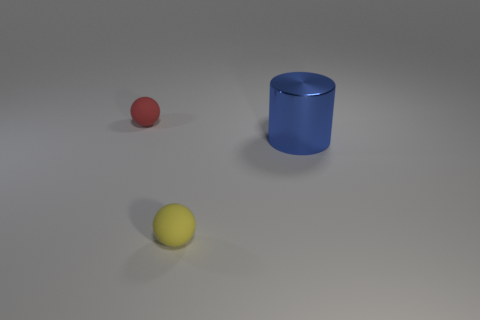Add 1 green spheres. How many objects exist? 4 Subtract 1 cylinders. How many cylinders are left? 0 Subtract all red spheres. How many spheres are left? 1 Subtract all blue spheres. How many yellow cylinders are left? 0 Subtract 0 red blocks. How many objects are left? 3 Subtract all cylinders. How many objects are left? 2 Subtract all red balls. Subtract all green cylinders. How many balls are left? 1 Subtract all yellow rubber spheres. Subtract all tiny balls. How many objects are left? 0 Add 3 small objects. How many small objects are left? 5 Add 3 blue objects. How many blue objects exist? 4 